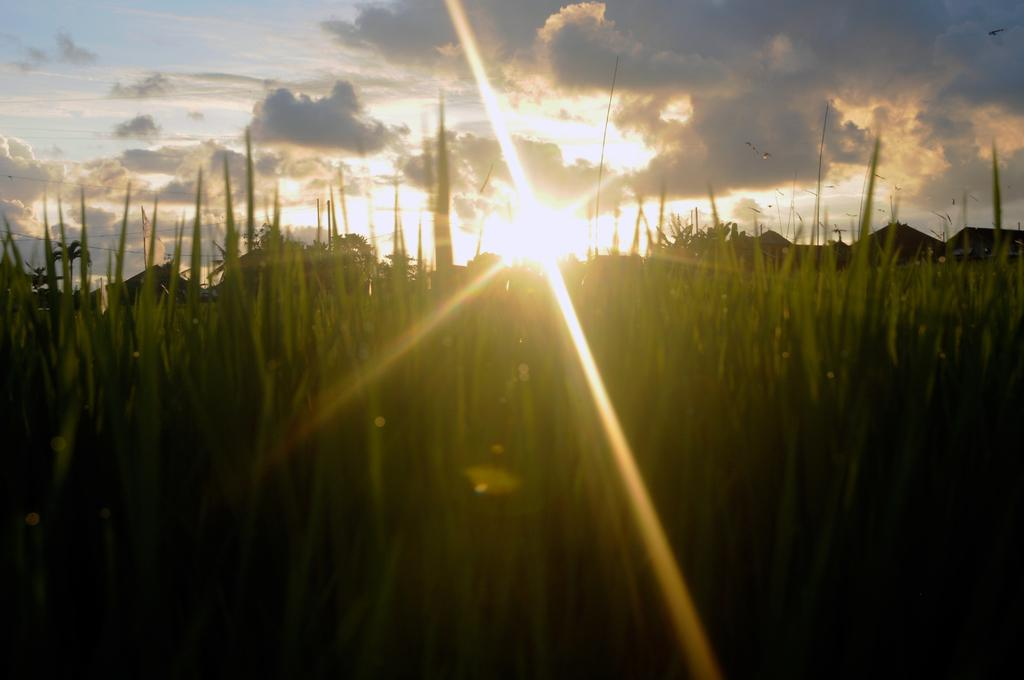What type of vegetation is present in the image? There is grass in the image. What can be seen in the distance behind the grass? Houses are visible in the background of the image. What else is present in the background of the image? Wires are present in the background of the image. What is the condition of the sky in the image? The sky appears cloudy in the image. Can you identify any celestial bodies in the image? Yes, the sun is visible in the image. What type of animal is causing a loss in the image? There is no animal or loss mentioned in the image; it only features grass, houses, wires, a cloudy sky, and the sun. 